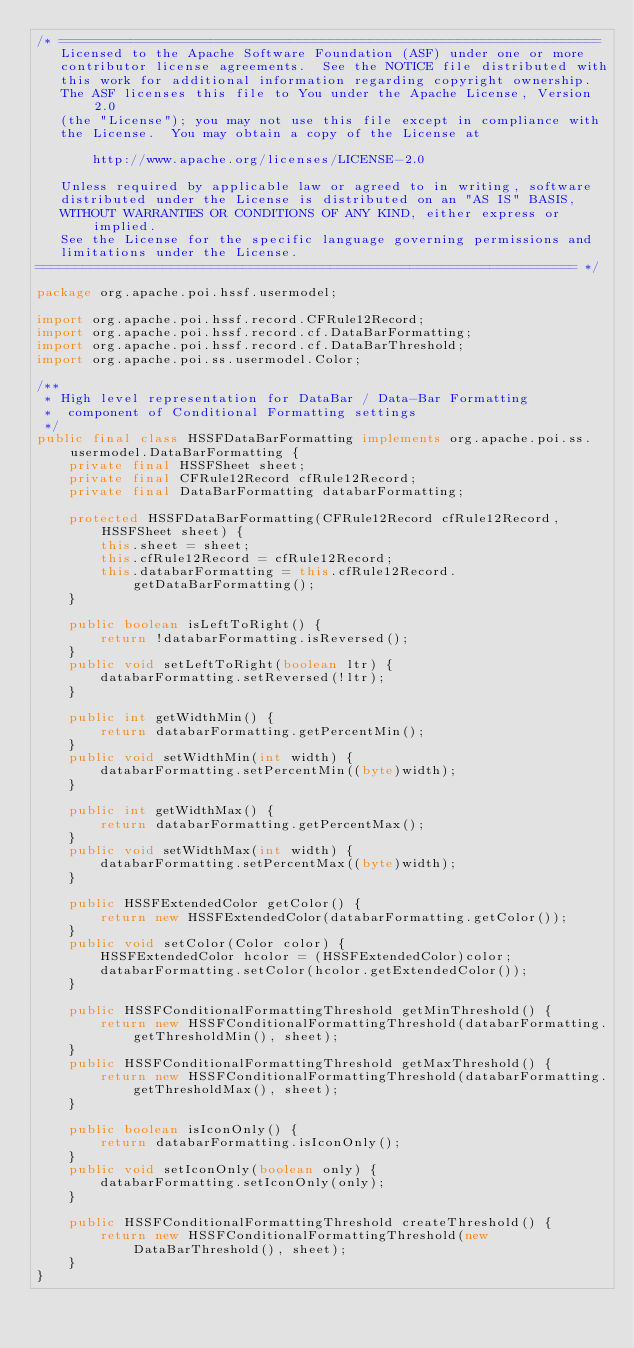<code> <loc_0><loc_0><loc_500><loc_500><_Java_>/* ====================================================================
   Licensed to the Apache Software Foundation (ASF) under one or more
   contributor license agreements.  See the NOTICE file distributed with
   this work for additional information regarding copyright ownership.
   The ASF licenses this file to You under the Apache License, Version 2.0
   (the "License"); you may not use this file except in compliance with
   the License.  You may obtain a copy of the License at

       http://www.apache.org/licenses/LICENSE-2.0

   Unless required by applicable law or agreed to in writing, software
   distributed under the License is distributed on an "AS IS" BASIS,
   WITHOUT WARRANTIES OR CONDITIONS OF ANY KIND, either express or implied.
   See the License for the specific language governing permissions and
   limitations under the License.
==================================================================== */

package org.apache.poi.hssf.usermodel;

import org.apache.poi.hssf.record.CFRule12Record;
import org.apache.poi.hssf.record.cf.DataBarFormatting;
import org.apache.poi.hssf.record.cf.DataBarThreshold;
import org.apache.poi.ss.usermodel.Color;

/**
 * High level representation for DataBar / Data-Bar Formatting 
 *  component of Conditional Formatting settings
 */
public final class HSSFDataBarFormatting implements org.apache.poi.ss.usermodel.DataBarFormatting {
    private final HSSFSheet sheet;
    private final CFRule12Record cfRule12Record;
    private final DataBarFormatting databarFormatting;

    protected HSSFDataBarFormatting(CFRule12Record cfRule12Record, HSSFSheet sheet) {
        this.sheet = sheet;
        this.cfRule12Record = cfRule12Record;
        this.databarFormatting = this.cfRule12Record.getDataBarFormatting();
    }

    public boolean isLeftToRight() {
        return !databarFormatting.isReversed();
    }
    public void setLeftToRight(boolean ltr) {
        databarFormatting.setReversed(!ltr);
    }

    public int getWidthMin() {
        return databarFormatting.getPercentMin();
    }
    public void setWidthMin(int width) {
        databarFormatting.setPercentMin((byte)width);
    }

    public int getWidthMax() {
        return databarFormatting.getPercentMax();
    }
    public void setWidthMax(int width) {
        databarFormatting.setPercentMax((byte)width);
    }

    public HSSFExtendedColor getColor() {
        return new HSSFExtendedColor(databarFormatting.getColor());
    }
    public void setColor(Color color) {
        HSSFExtendedColor hcolor = (HSSFExtendedColor)color;
        databarFormatting.setColor(hcolor.getExtendedColor());
    }

    public HSSFConditionalFormattingThreshold getMinThreshold() {
        return new HSSFConditionalFormattingThreshold(databarFormatting.getThresholdMin(), sheet);
    }
    public HSSFConditionalFormattingThreshold getMaxThreshold() {
        return new HSSFConditionalFormattingThreshold(databarFormatting.getThresholdMax(), sheet);
    }

    public boolean isIconOnly() {
        return databarFormatting.isIconOnly();
    }
    public void setIconOnly(boolean only) {
        databarFormatting.setIconOnly(only);
    }

    public HSSFConditionalFormattingThreshold createThreshold() {
        return new HSSFConditionalFormattingThreshold(new DataBarThreshold(), sheet);
    }
}
</code> 